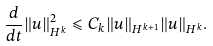Convert formula to latex. <formula><loc_0><loc_0><loc_500><loc_500>\frac { d } { d t } \| { u } \| _ { H ^ { k } } ^ { 2 } \leqslant C _ { k } \| { u } \| _ { H ^ { k + 1 } } \| { u } \| _ { H ^ { k } } .</formula> 